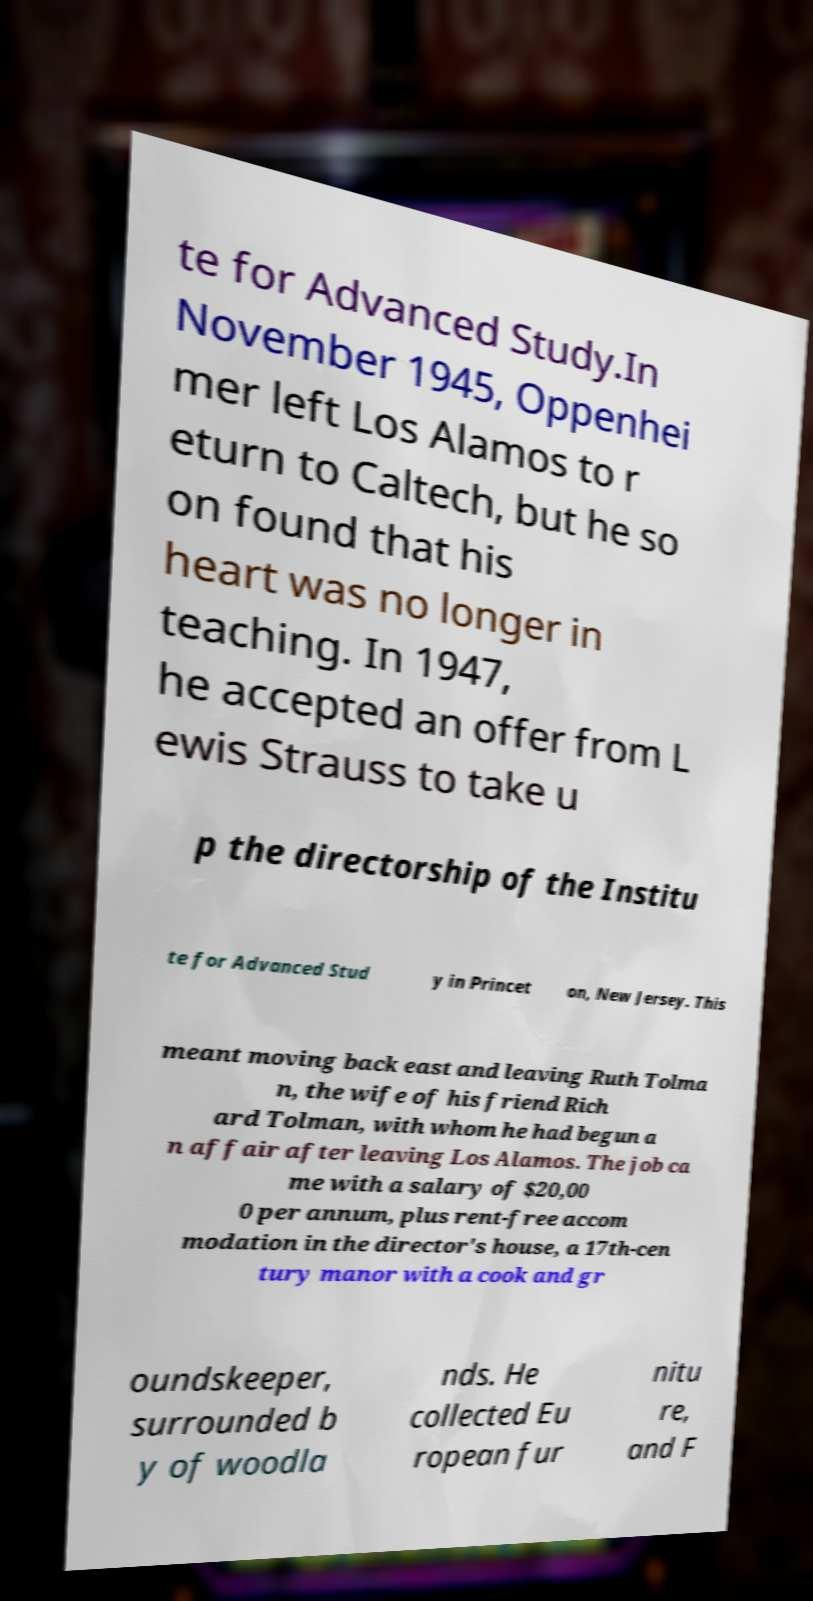Could you assist in decoding the text presented in this image and type it out clearly? te for Advanced Study.In November 1945, Oppenhei mer left Los Alamos to r eturn to Caltech, but he so on found that his heart was no longer in teaching. In 1947, he accepted an offer from L ewis Strauss to take u p the directorship of the Institu te for Advanced Stud y in Princet on, New Jersey. This meant moving back east and leaving Ruth Tolma n, the wife of his friend Rich ard Tolman, with whom he had begun a n affair after leaving Los Alamos. The job ca me with a salary of $20,00 0 per annum, plus rent-free accom modation in the director's house, a 17th-cen tury manor with a cook and gr oundskeeper, surrounded b y of woodla nds. He collected Eu ropean fur nitu re, and F 